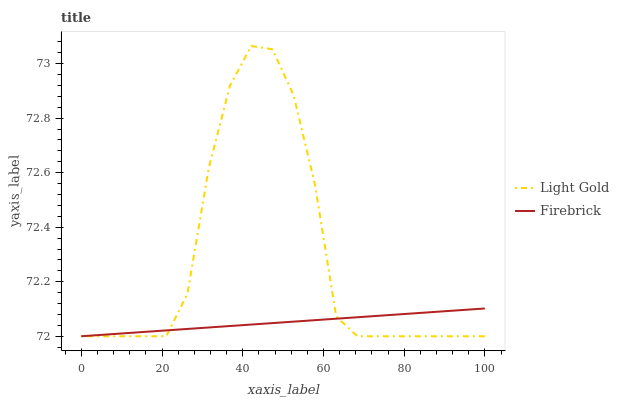Does Firebrick have the minimum area under the curve?
Answer yes or no. Yes. Does Light Gold have the maximum area under the curve?
Answer yes or no. Yes. Does Light Gold have the minimum area under the curve?
Answer yes or no. No. Is Firebrick the smoothest?
Answer yes or no. Yes. Is Light Gold the roughest?
Answer yes or no. Yes. Is Light Gold the smoothest?
Answer yes or no. No. Does Light Gold have the highest value?
Answer yes or no. Yes. Does Light Gold intersect Firebrick?
Answer yes or no. Yes. Is Light Gold less than Firebrick?
Answer yes or no. No. Is Light Gold greater than Firebrick?
Answer yes or no. No. 